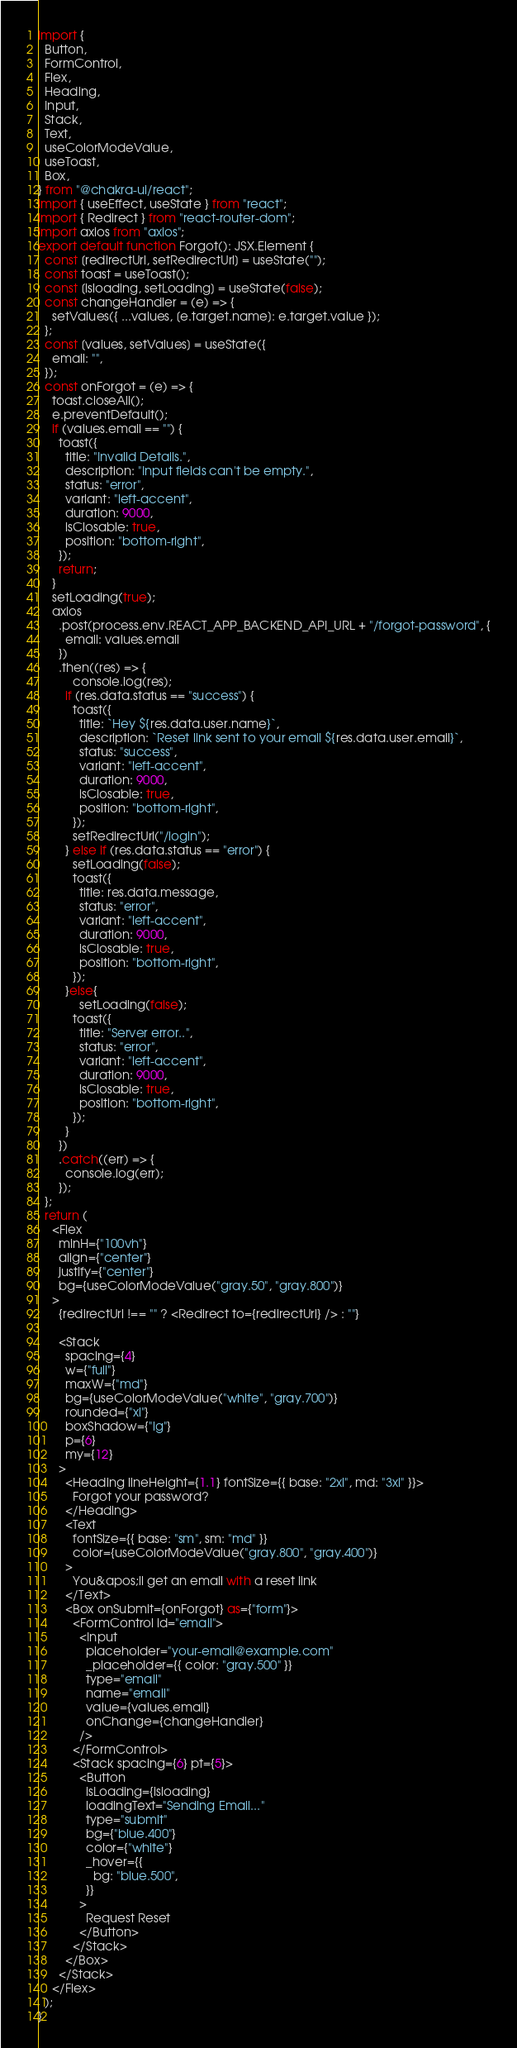Convert code to text. <code><loc_0><loc_0><loc_500><loc_500><_JavaScript_>import {
  Button,
  FormControl,
  Flex,
  Heading,
  Input,
  Stack,
  Text,
  useColorModeValue,
  useToast,
  Box,
} from "@chakra-ui/react";
import { useEffect, useState } from "react";
import { Redirect } from "react-router-dom";
import axios from "axios";
export default function Forgot(): JSX.Element {
  const [redirectUrl, setRedirectUrl] = useState("");
  const toast = useToast();
  const [isloading, setLoading] = useState(false);
  const changeHandler = (e) => {
    setValues({ ...values, [e.target.name]: e.target.value });
  };
  const [values, setValues] = useState({
    email: "",
  });
  const onForgot = (e) => {
    toast.closeAll();
    e.preventDefault();
    if (values.email == "") {
      toast({
        title: "Invalid Details.",
        description: "Input fields can't be empty.",
        status: "error",
        variant: "left-accent",
        duration: 9000,
        isClosable: true,
        position: "bottom-right",
      });
      return;
    }
    setLoading(true);
    axios
      .post(process.env.REACT_APP_BACKEND_API_URL + "/forgot-password", {
        email: values.email
      })
      .then((res) => {
          console.log(res);
        if (res.data.status == "success") {
          toast({
            title: `Hey ${res.data.user.name}`,
            description: `Reset link sent to your email ${res.data.user.email}`,
            status: "success",
            variant: "left-accent",
            duration: 9000,
            isClosable: true,
            position: "bottom-right",
          });
          setRedirectUrl("/login");
        } else if (res.data.status == "error") {
          setLoading(false);
          toast({
            title: res.data.message,
            status: "error",
            variant: "left-accent",
            duration: 9000,
            isClosable: true,
            position: "bottom-right",
          });
        }else{
            setLoading(false);
          toast({
            title: "Server error..",
            status: "error",
            variant: "left-accent",
            duration: 9000,
            isClosable: true,
            position: "bottom-right",
          });
        }
      })
      .catch((err) => {
        console.log(err);
      });
  };
  return (
    <Flex
      minH={"100vh"}
      align={"center"}
      justify={"center"}
      bg={useColorModeValue("gray.50", "gray.800")}
    >
      {redirectUrl !== "" ? <Redirect to={redirectUrl} /> : ""}

      <Stack
        spacing={4}
        w={"full"}
        maxW={"md"}
        bg={useColorModeValue("white", "gray.700")}
        rounded={"xl"}
        boxShadow={"lg"}
        p={6}
        my={12}
      >
        <Heading lineHeight={1.1} fontSize={{ base: "2xl", md: "3xl" }}>
          Forgot your password?
        </Heading>
        <Text
          fontSize={{ base: "sm", sm: "md" }}
          color={useColorModeValue("gray.800", "gray.400")}
        >
          You&apos;ll get an email with a reset link
        </Text>
        <Box onSubmit={onForgot} as={"form"}>
          <FormControl id="email">
            <Input
              placeholder="your-email@example.com"
              _placeholder={{ color: "gray.500" }}
              type="email"
              name="email"
              value={values.email}
              onChange={changeHandler}
            />
          </FormControl>
          <Stack spacing={6} pt={5}>
            <Button
              isLoading={isloading}
              loadingText="Sending Email..."
              type="submit"
              bg={"blue.400"}
              color={"white"}
              _hover={{
                bg: "blue.500",
              }}
            >
              Request Reset
            </Button>
          </Stack>
        </Box>
      </Stack>
    </Flex>
  );
}
</code> 